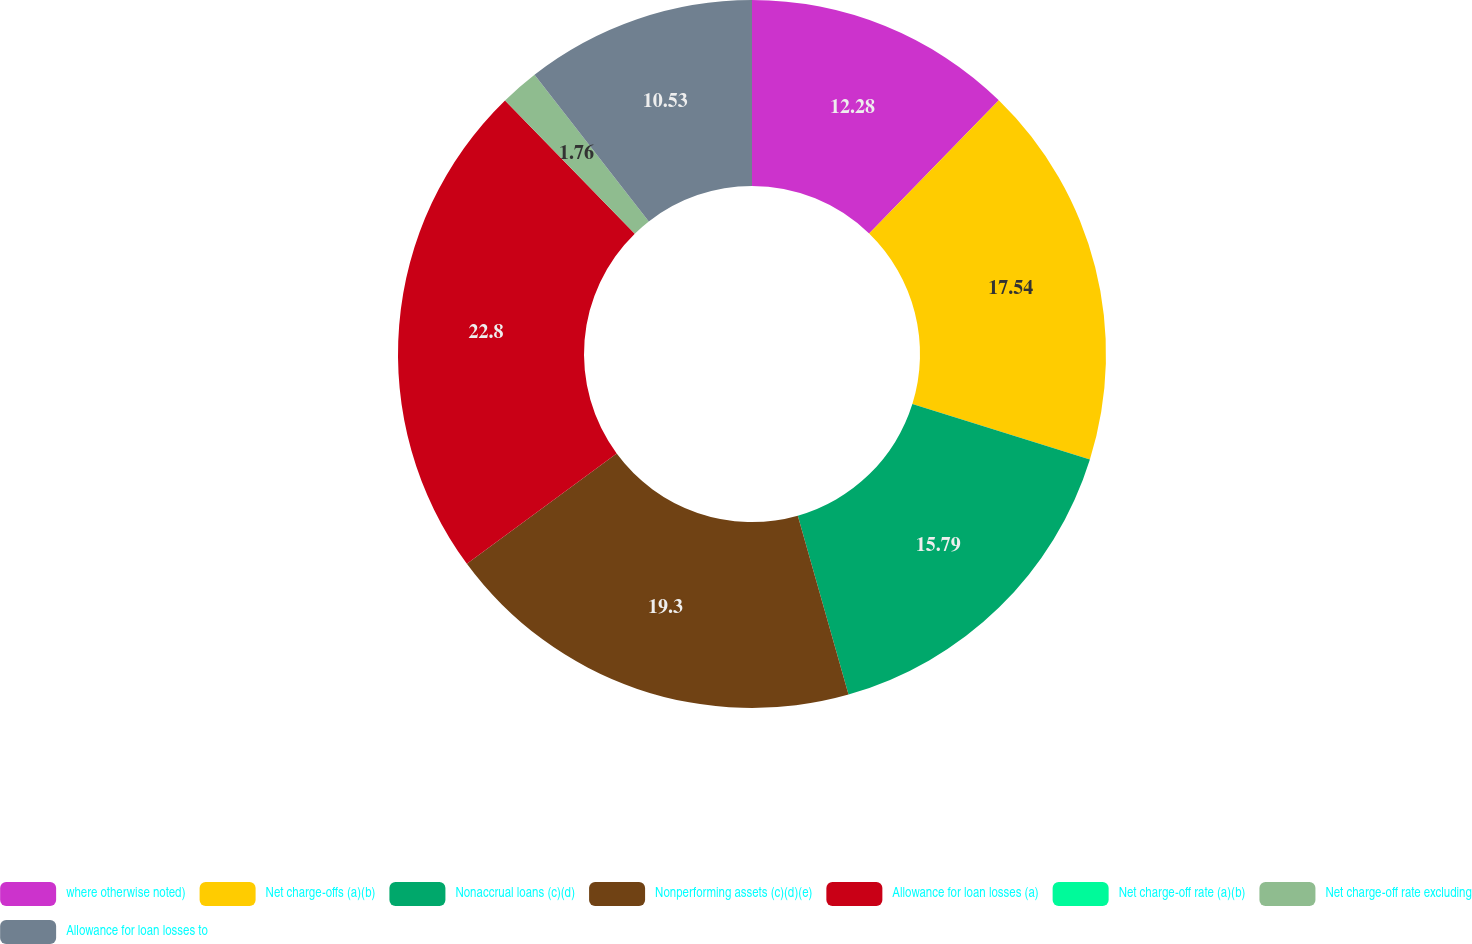Convert chart to OTSL. <chart><loc_0><loc_0><loc_500><loc_500><pie_chart><fcel>where otherwise noted)<fcel>Net charge-offs (a)(b)<fcel>Nonaccrual loans (c)(d)<fcel>Nonperforming assets (c)(d)(e)<fcel>Allowance for loan losses (a)<fcel>Net charge-off rate (a)(b)<fcel>Net charge-off rate excluding<fcel>Allowance for loan losses to<nl><fcel>12.28%<fcel>17.54%<fcel>15.79%<fcel>19.3%<fcel>22.81%<fcel>0.0%<fcel>1.76%<fcel>10.53%<nl></chart> 